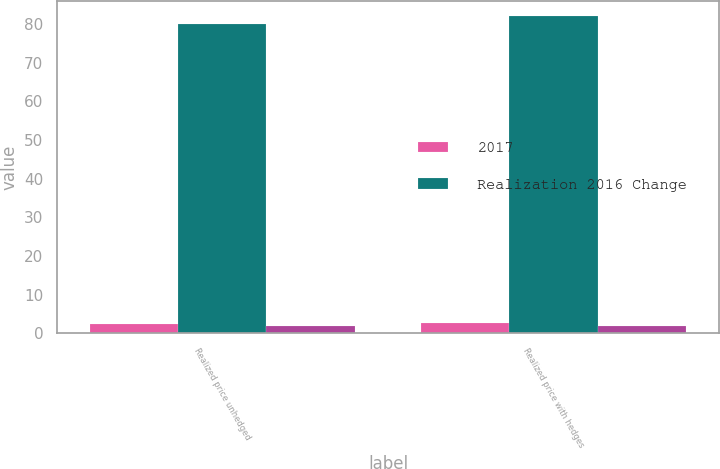Convert chart to OTSL. <chart><loc_0><loc_0><loc_500><loc_500><stacked_bar_chart><ecel><fcel>Realized price unhedged<fcel>Realized price with hedges<nl><fcel>2017<fcel>2.48<fcel>2.56<nl><fcel>Realization 2016 Change<fcel>80<fcel>82<nl><fcel>nan<fcel>1.84<fcel>1.91<nl></chart> 